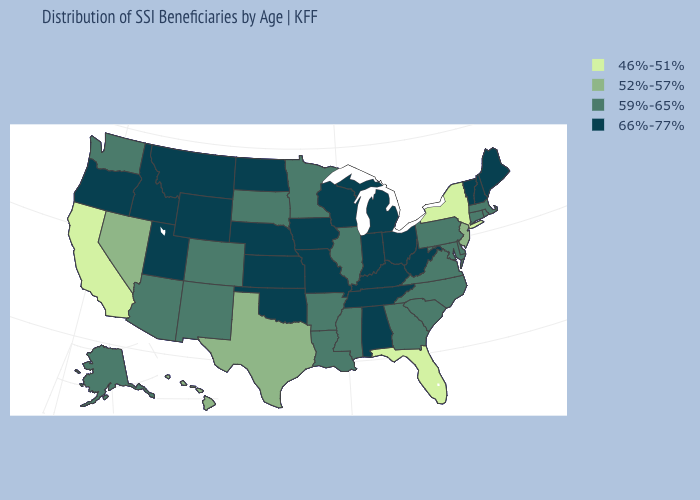What is the lowest value in the MidWest?
Give a very brief answer. 59%-65%. Does Illinois have a higher value than Texas?
Concise answer only. Yes. Does the map have missing data?
Concise answer only. No. Name the states that have a value in the range 46%-51%?
Write a very short answer. California, Florida, New York. Which states have the lowest value in the Northeast?
Give a very brief answer. New York. Which states have the lowest value in the MidWest?
Quick response, please. Illinois, Minnesota, South Dakota. Name the states that have a value in the range 52%-57%?
Write a very short answer. Hawaii, Nevada, New Jersey, Texas. What is the highest value in states that border Indiana?
Write a very short answer. 66%-77%. What is the value of Arizona?
Be succinct. 59%-65%. Name the states that have a value in the range 46%-51%?
Give a very brief answer. California, Florida, New York. Which states hav the highest value in the Northeast?
Write a very short answer. Maine, New Hampshire, Vermont. Among the states that border California , does Nevada have the lowest value?
Keep it brief. Yes. Name the states that have a value in the range 59%-65%?
Concise answer only. Alaska, Arizona, Arkansas, Colorado, Connecticut, Delaware, Georgia, Illinois, Louisiana, Maryland, Massachusetts, Minnesota, Mississippi, New Mexico, North Carolina, Pennsylvania, Rhode Island, South Carolina, South Dakota, Virginia, Washington. What is the lowest value in the USA?
Answer briefly. 46%-51%. Does the first symbol in the legend represent the smallest category?
Quick response, please. Yes. 